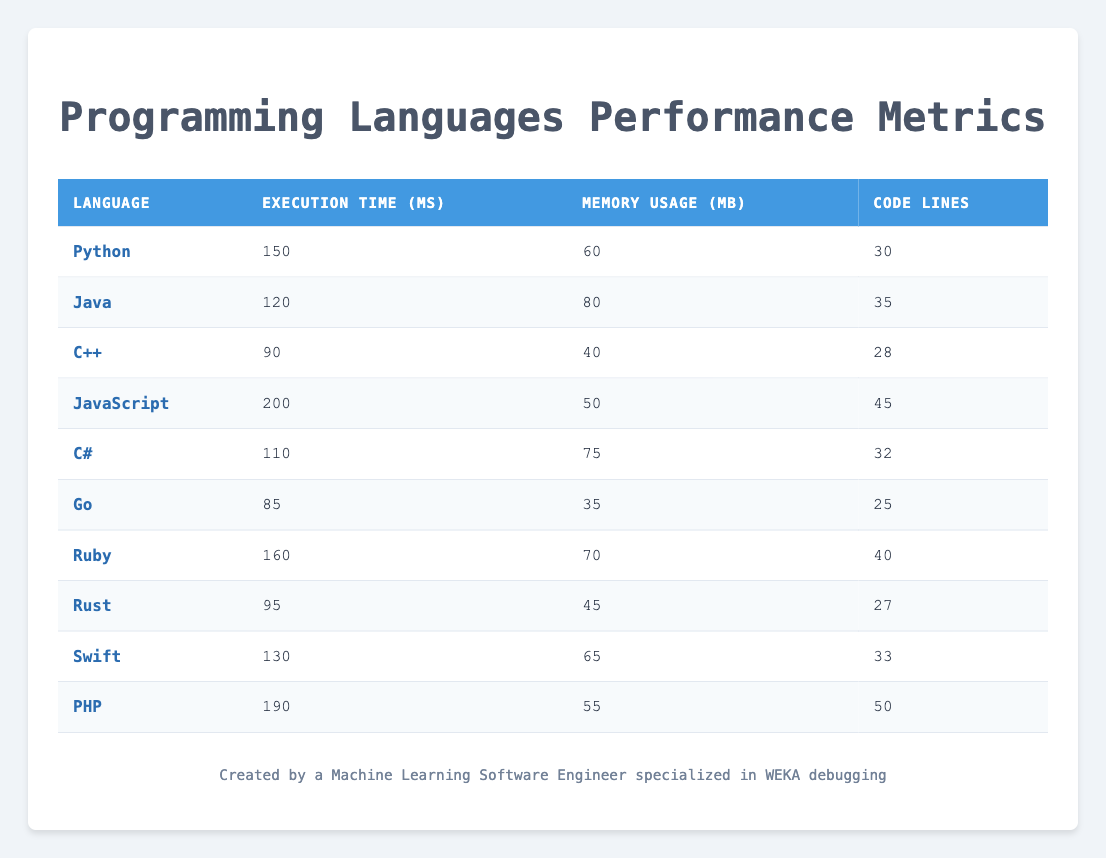What is the execution time of C#? The table shows that the execution time for C# is listed as 110 ms.
Answer: 110 ms Which programming language has the highest memory usage? By comparing the Memory Usage column in the table, Java has the highest value at 80 MB.
Answer: Java How many lines of code are there in Go? In the table, under Code Lines, Go is noted to have 25 lines of code.
Answer: 25 What is the average execution time of all languages? First, sum all execution times: (150 + 120 + 90 + 200 + 110 + 85 + 160 + 95 + 130 + 190) = 1,330 ms. There are 10 languages, so the average is 1,330/10 = 133 ms.
Answer: 133 ms Is the execution time of Ruby less than that of JavaScript? Ruby has an execution time of 160 ms, while JavaScript has 200 ms. Since 160 is less than 200, the answer is yes.
Answer: Yes Which language has the most lines of code and what is that number? By checking the Code Lines column, PHP has the most lines at 50.
Answer: PHP, 50 How much more memory does Java use compared to Go? Java uses 80 MB and Go uses 35 MB. The difference is 80 - 35 = 45 MB.
Answer: 45 MB Which programming language has the lowest execution time? Looking at the Execution Time column, Go has the lowest execution time at 85 ms.
Answer: Go What is the median memory usage among these programming languages? To find the median, first, sort the Memory Usage values: 35, 40, 45, 50, 55, 60, 65, 70, 75, 80. With 10 values, the median is the average of the 5th and 6th values: (55 + 60) / 2 = 57.5 MB.
Answer: 57.5 MB 